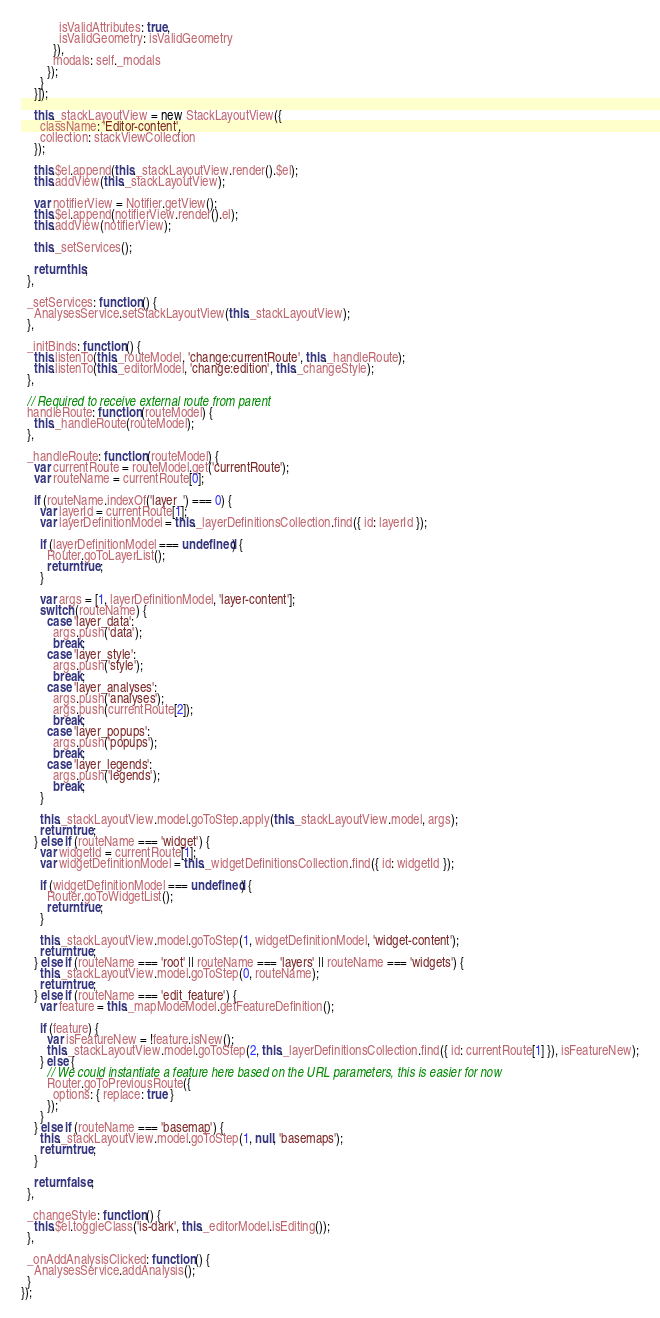<code> <loc_0><loc_0><loc_500><loc_500><_JavaScript_>            isValidAttributes: true,
            isValidGeometry: isValidGeometry
          }),
          modals: self._modals
        });
      }
    }]);

    this._stackLayoutView = new StackLayoutView({
      className: 'Editor-content',
      collection: stackViewCollection
    });

    this.$el.append(this._stackLayoutView.render().$el);
    this.addView(this._stackLayoutView);

    var notifierView = Notifier.getView();
    this.$el.append(notifierView.render().el);
    this.addView(notifierView);

    this._setServices();

    return this;
  },

  _setServices: function () {
    AnalysesService.setStackLayoutView(this._stackLayoutView);
  },

  _initBinds: function () {
    this.listenTo(this._routeModel, 'change:currentRoute', this._handleRoute);
    this.listenTo(this._editorModel, 'change:edition', this._changeStyle);
  },

  // Required to receive external route from parent
  handleRoute: function (routeModel) {
    this._handleRoute(routeModel);
  },

  _handleRoute: function (routeModel) {
    var currentRoute = routeModel.get('currentRoute');
    var routeName = currentRoute[0];

    if (routeName.indexOf('layer_') === 0) {
      var layerId = currentRoute[1];
      var layerDefinitionModel = this._layerDefinitionsCollection.find({ id: layerId });

      if (layerDefinitionModel === undefined) {
        Router.goToLayerList();
        return true;
      }

      var args = [1, layerDefinitionModel, 'layer-content'];
      switch (routeName) {
        case 'layer_data':
          args.push('data');
          break;
        case 'layer_style':
          args.push('style');
          break;
        case 'layer_analyses':
          args.push('analyses');
          args.push(currentRoute[2]);
          break;
        case 'layer_popups':
          args.push('popups');
          break;
        case 'layer_legends':
          args.push('legends');
          break;
      }

      this._stackLayoutView.model.goToStep.apply(this._stackLayoutView.model, args);
      return true;
    } else if (routeName === 'widget') {
      var widgetId = currentRoute[1];
      var widgetDefinitionModel = this._widgetDefinitionsCollection.find({ id: widgetId });

      if (widgetDefinitionModel === undefined) {
        Router.goToWidgetList();
        return true;
      }

      this._stackLayoutView.model.goToStep(1, widgetDefinitionModel, 'widget-content');
      return true;
    } else if (routeName === 'root' || routeName === 'layers' || routeName === 'widgets') {
      this._stackLayoutView.model.goToStep(0, routeName);
      return true;
    } else if (routeName === 'edit_feature') {
      var feature = this._mapModeModel.getFeatureDefinition();

      if (feature) {
        var isFeatureNew = !feature.isNew();
        this._stackLayoutView.model.goToStep(2, this._layerDefinitionsCollection.find({ id: currentRoute[1] }), isFeatureNew);
      } else {
        // We could instantiate a feature here based on the URL parameters, this is easier for now
        Router.goToPreviousRoute({
          options: { replace: true }
        });
      }
    } else if (routeName === 'basemap') {
      this._stackLayoutView.model.goToStep(1, null, 'basemaps');
      return true;
    }

    return false;
  },

  _changeStyle: function () {
    this.$el.toggleClass('is-dark', this._editorModel.isEditing());
  },

  _onAddAnalysisClicked: function () {
    AnalysesService.addAnalysis();
  }
});
</code> 